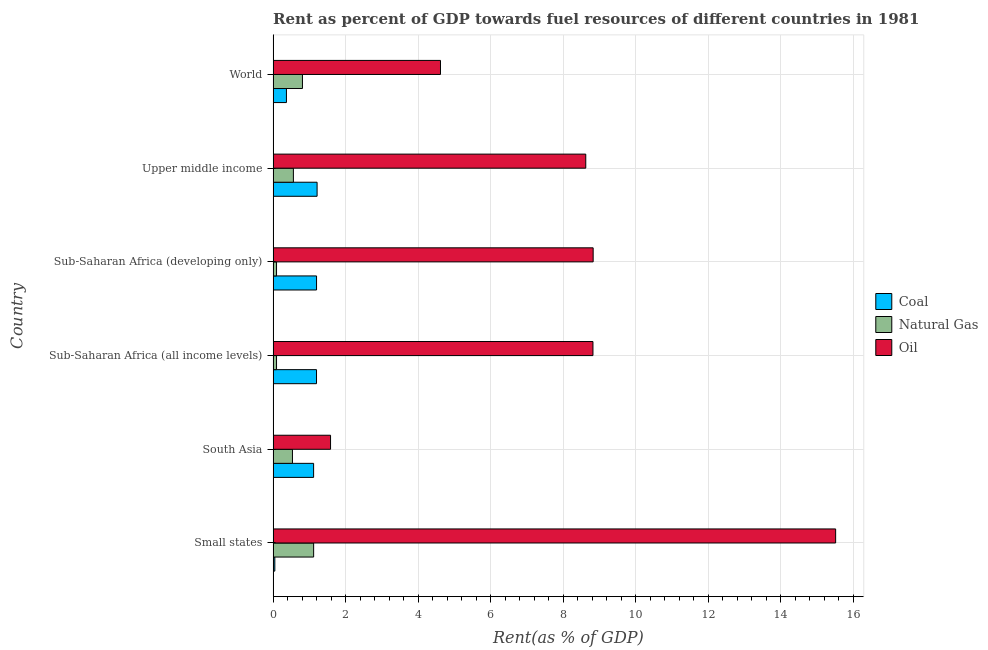How many different coloured bars are there?
Your response must be concise. 3. Are the number of bars per tick equal to the number of legend labels?
Your response must be concise. Yes. Are the number of bars on each tick of the Y-axis equal?
Your response must be concise. Yes. What is the label of the 5th group of bars from the top?
Ensure brevity in your answer.  South Asia. What is the rent towards oil in South Asia?
Your response must be concise. 1.58. Across all countries, what is the maximum rent towards coal?
Offer a very short reply. 1.21. Across all countries, what is the minimum rent towards coal?
Provide a short and direct response. 0.05. In which country was the rent towards oil maximum?
Provide a short and direct response. Small states. In which country was the rent towards natural gas minimum?
Provide a succinct answer. Sub-Saharan Africa (all income levels). What is the total rent towards coal in the graph?
Offer a terse response. 5.14. What is the difference between the rent towards natural gas in Sub-Saharan Africa (developing only) and that in Upper middle income?
Offer a very short reply. -0.47. What is the difference between the rent towards coal in World and the rent towards natural gas in Upper middle income?
Give a very brief answer. -0.19. What is the average rent towards oil per country?
Your answer should be very brief. 8. What is the difference between the rent towards coal and rent towards oil in Small states?
Offer a terse response. -15.46. In how many countries, is the rent towards oil greater than 4 %?
Your answer should be compact. 5. What is the ratio of the rent towards oil in Small states to that in Sub-Saharan Africa (all income levels)?
Provide a succinct answer. 1.76. Is the rent towards oil in South Asia less than that in Sub-Saharan Africa (all income levels)?
Provide a succinct answer. Yes. What is the difference between the highest and the second highest rent towards natural gas?
Ensure brevity in your answer.  0.31. What is the difference between the highest and the lowest rent towards coal?
Make the answer very short. 1.17. In how many countries, is the rent towards oil greater than the average rent towards oil taken over all countries?
Your answer should be very brief. 4. What does the 2nd bar from the top in Sub-Saharan Africa (developing only) represents?
Make the answer very short. Natural Gas. What does the 2nd bar from the bottom in Sub-Saharan Africa (all income levels) represents?
Offer a terse response. Natural Gas. How many bars are there?
Ensure brevity in your answer.  18. How many countries are there in the graph?
Ensure brevity in your answer.  6. Does the graph contain grids?
Offer a very short reply. Yes. Where does the legend appear in the graph?
Your answer should be very brief. Center right. How many legend labels are there?
Offer a terse response. 3. How are the legend labels stacked?
Provide a succinct answer. Vertical. What is the title of the graph?
Give a very brief answer. Rent as percent of GDP towards fuel resources of different countries in 1981. Does "Spain" appear as one of the legend labels in the graph?
Ensure brevity in your answer.  No. What is the label or title of the X-axis?
Keep it short and to the point. Rent(as % of GDP). What is the Rent(as % of GDP) in Coal in Small states?
Your response must be concise. 0.05. What is the Rent(as % of GDP) in Natural Gas in Small states?
Provide a succinct answer. 1.12. What is the Rent(as % of GDP) in Oil in Small states?
Your response must be concise. 15.51. What is the Rent(as % of GDP) of Coal in South Asia?
Give a very brief answer. 1.12. What is the Rent(as % of GDP) of Natural Gas in South Asia?
Ensure brevity in your answer.  0.53. What is the Rent(as % of GDP) of Oil in South Asia?
Offer a terse response. 1.58. What is the Rent(as % of GDP) of Coal in Sub-Saharan Africa (all income levels)?
Your answer should be very brief. 1.2. What is the Rent(as % of GDP) in Natural Gas in Sub-Saharan Africa (all income levels)?
Provide a short and direct response. 0.09. What is the Rent(as % of GDP) in Oil in Sub-Saharan Africa (all income levels)?
Provide a short and direct response. 8.82. What is the Rent(as % of GDP) of Coal in Sub-Saharan Africa (developing only)?
Keep it short and to the point. 1.2. What is the Rent(as % of GDP) in Natural Gas in Sub-Saharan Africa (developing only)?
Offer a very short reply. 0.09. What is the Rent(as % of GDP) of Oil in Sub-Saharan Africa (developing only)?
Give a very brief answer. 8.82. What is the Rent(as % of GDP) of Coal in Upper middle income?
Ensure brevity in your answer.  1.21. What is the Rent(as % of GDP) of Natural Gas in Upper middle income?
Ensure brevity in your answer.  0.56. What is the Rent(as % of GDP) of Oil in Upper middle income?
Provide a succinct answer. 8.62. What is the Rent(as % of GDP) of Coal in World?
Keep it short and to the point. 0.37. What is the Rent(as % of GDP) in Natural Gas in World?
Provide a succinct answer. 0.81. What is the Rent(as % of GDP) of Oil in World?
Your answer should be compact. 4.61. Across all countries, what is the maximum Rent(as % of GDP) in Coal?
Your answer should be compact. 1.21. Across all countries, what is the maximum Rent(as % of GDP) of Natural Gas?
Your response must be concise. 1.12. Across all countries, what is the maximum Rent(as % of GDP) in Oil?
Your answer should be compact. 15.51. Across all countries, what is the minimum Rent(as % of GDP) of Coal?
Offer a terse response. 0.05. Across all countries, what is the minimum Rent(as % of GDP) of Natural Gas?
Provide a succinct answer. 0.09. Across all countries, what is the minimum Rent(as % of GDP) in Oil?
Make the answer very short. 1.58. What is the total Rent(as % of GDP) of Coal in the graph?
Your answer should be very brief. 5.14. What is the total Rent(as % of GDP) of Natural Gas in the graph?
Keep it short and to the point. 3.21. What is the total Rent(as % of GDP) in Oil in the graph?
Keep it short and to the point. 47.97. What is the difference between the Rent(as % of GDP) in Coal in Small states and that in South Asia?
Your answer should be very brief. -1.07. What is the difference between the Rent(as % of GDP) in Natural Gas in Small states and that in South Asia?
Ensure brevity in your answer.  0.58. What is the difference between the Rent(as % of GDP) of Oil in Small states and that in South Asia?
Ensure brevity in your answer.  13.93. What is the difference between the Rent(as % of GDP) in Coal in Small states and that in Sub-Saharan Africa (all income levels)?
Your response must be concise. -1.15. What is the difference between the Rent(as % of GDP) of Natural Gas in Small states and that in Sub-Saharan Africa (all income levels)?
Provide a succinct answer. 1.02. What is the difference between the Rent(as % of GDP) of Oil in Small states and that in Sub-Saharan Africa (all income levels)?
Your response must be concise. 6.69. What is the difference between the Rent(as % of GDP) of Coal in Small states and that in Sub-Saharan Africa (developing only)?
Keep it short and to the point. -1.15. What is the difference between the Rent(as % of GDP) in Natural Gas in Small states and that in Sub-Saharan Africa (developing only)?
Your answer should be compact. 1.02. What is the difference between the Rent(as % of GDP) in Oil in Small states and that in Sub-Saharan Africa (developing only)?
Provide a short and direct response. 6.69. What is the difference between the Rent(as % of GDP) of Coal in Small states and that in Upper middle income?
Provide a short and direct response. -1.17. What is the difference between the Rent(as % of GDP) in Natural Gas in Small states and that in Upper middle income?
Your answer should be very brief. 0.56. What is the difference between the Rent(as % of GDP) in Oil in Small states and that in Upper middle income?
Offer a very short reply. 6.89. What is the difference between the Rent(as % of GDP) of Coal in Small states and that in World?
Your response must be concise. -0.32. What is the difference between the Rent(as % of GDP) of Natural Gas in Small states and that in World?
Your answer should be compact. 0.31. What is the difference between the Rent(as % of GDP) in Oil in Small states and that in World?
Offer a terse response. 10.9. What is the difference between the Rent(as % of GDP) of Coal in South Asia and that in Sub-Saharan Africa (all income levels)?
Your answer should be very brief. -0.08. What is the difference between the Rent(as % of GDP) in Natural Gas in South Asia and that in Sub-Saharan Africa (all income levels)?
Make the answer very short. 0.44. What is the difference between the Rent(as % of GDP) of Oil in South Asia and that in Sub-Saharan Africa (all income levels)?
Ensure brevity in your answer.  -7.23. What is the difference between the Rent(as % of GDP) in Coal in South Asia and that in Sub-Saharan Africa (developing only)?
Make the answer very short. -0.08. What is the difference between the Rent(as % of GDP) of Natural Gas in South Asia and that in Sub-Saharan Africa (developing only)?
Your response must be concise. 0.44. What is the difference between the Rent(as % of GDP) of Oil in South Asia and that in Sub-Saharan Africa (developing only)?
Your answer should be compact. -7.24. What is the difference between the Rent(as % of GDP) in Coal in South Asia and that in Upper middle income?
Your answer should be very brief. -0.1. What is the difference between the Rent(as % of GDP) in Natural Gas in South Asia and that in Upper middle income?
Make the answer very short. -0.03. What is the difference between the Rent(as % of GDP) in Oil in South Asia and that in Upper middle income?
Your answer should be compact. -7.04. What is the difference between the Rent(as % of GDP) of Coal in South Asia and that in World?
Your response must be concise. 0.75. What is the difference between the Rent(as % of GDP) in Natural Gas in South Asia and that in World?
Your answer should be very brief. -0.28. What is the difference between the Rent(as % of GDP) of Oil in South Asia and that in World?
Ensure brevity in your answer.  -3.03. What is the difference between the Rent(as % of GDP) of Coal in Sub-Saharan Africa (all income levels) and that in Sub-Saharan Africa (developing only)?
Your response must be concise. -0. What is the difference between the Rent(as % of GDP) of Natural Gas in Sub-Saharan Africa (all income levels) and that in Sub-Saharan Africa (developing only)?
Your answer should be very brief. -0. What is the difference between the Rent(as % of GDP) of Oil in Sub-Saharan Africa (all income levels) and that in Sub-Saharan Africa (developing only)?
Give a very brief answer. -0.01. What is the difference between the Rent(as % of GDP) in Coal in Sub-Saharan Africa (all income levels) and that in Upper middle income?
Your answer should be compact. -0.02. What is the difference between the Rent(as % of GDP) in Natural Gas in Sub-Saharan Africa (all income levels) and that in Upper middle income?
Provide a short and direct response. -0.46. What is the difference between the Rent(as % of GDP) in Oil in Sub-Saharan Africa (all income levels) and that in Upper middle income?
Provide a succinct answer. 0.2. What is the difference between the Rent(as % of GDP) in Coal in Sub-Saharan Africa (all income levels) and that in World?
Give a very brief answer. 0.83. What is the difference between the Rent(as % of GDP) in Natural Gas in Sub-Saharan Africa (all income levels) and that in World?
Keep it short and to the point. -0.71. What is the difference between the Rent(as % of GDP) in Oil in Sub-Saharan Africa (all income levels) and that in World?
Your response must be concise. 4.2. What is the difference between the Rent(as % of GDP) of Coal in Sub-Saharan Africa (developing only) and that in Upper middle income?
Your response must be concise. -0.01. What is the difference between the Rent(as % of GDP) in Natural Gas in Sub-Saharan Africa (developing only) and that in Upper middle income?
Provide a succinct answer. -0.46. What is the difference between the Rent(as % of GDP) of Oil in Sub-Saharan Africa (developing only) and that in Upper middle income?
Your response must be concise. 0.2. What is the difference between the Rent(as % of GDP) in Coal in Sub-Saharan Africa (developing only) and that in World?
Offer a terse response. 0.83. What is the difference between the Rent(as % of GDP) of Natural Gas in Sub-Saharan Africa (developing only) and that in World?
Keep it short and to the point. -0.71. What is the difference between the Rent(as % of GDP) of Oil in Sub-Saharan Africa (developing only) and that in World?
Offer a terse response. 4.21. What is the difference between the Rent(as % of GDP) of Coal in Upper middle income and that in World?
Your answer should be compact. 0.85. What is the difference between the Rent(as % of GDP) of Natural Gas in Upper middle income and that in World?
Provide a short and direct response. -0.25. What is the difference between the Rent(as % of GDP) in Oil in Upper middle income and that in World?
Ensure brevity in your answer.  4.01. What is the difference between the Rent(as % of GDP) of Coal in Small states and the Rent(as % of GDP) of Natural Gas in South Asia?
Your answer should be compact. -0.49. What is the difference between the Rent(as % of GDP) in Coal in Small states and the Rent(as % of GDP) in Oil in South Asia?
Keep it short and to the point. -1.54. What is the difference between the Rent(as % of GDP) of Natural Gas in Small states and the Rent(as % of GDP) of Oil in South Asia?
Your response must be concise. -0.47. What is the difference between the Rent(as % of GDP) of Coal in Small states and the Rent(as % of GDP) of Natural Gas in Sub-Saharan Africa (all income levels)?
Your answer should be compact. -0.05. What is the difference between the Rent(as % of GDP) of Coal in Small states and the Rent(as % of GDP) of Oil in Sub-Saharan Africa (all income levels)?
Offer a terse response. -8.77. What is the difference between the Rent(as % of GDP) in Natural Gas in Small states and the Rent(as % of GDP) in Oil in Sub-Saharan Africa (all income levels)?
Offer a terse response. -7.7. What is the difference between the Rent(as % of GDP) of Coal in Small states and the Rent(as % of GDP) of Natural Gas in Sub-Saharan Africa (developing only)?
Offer a very short reply. -0.05. What is the difference between the Rent(as % of GDP) in Coal in Small states and the Rent(as % of GDP) in Oil in Sub-Saharan Africa (developing only)?
Offer a terse response. -8.78. What is the difference between the Rent(as % of GDP) of Natural Gas in Small states and the Rent(as % of GDP) of Oil in Sub-Saharan Africa (developing only)?
Keep it short and to the point. -7.71. What is the difference between the Rent(as % of GDP) of Coal in Small states and the Rent(as % of GDP) of Natural Gas in Upper middle income?
Your answer should be very brief. -0.51. What is the difference between the Rent(as % of GDP) in Coal in Small states and the Rent(as % of GDP) in Oil in Upper middle income?
Provide a short and direct response. -8.57. What is the difference between the Rent(as % of GDP) in Natural Gas in Small states and the Rent(as % of GDP) in Oil in Upper middle income?
Make the answer very short. -7.5. What is the difference between the Rent(as % of GDP) of Coal in Small states and the Rent(as % of GDP) of Natural Gas in World?
Ensure brevity in your answer.  -0.76. What is the difference between the Rent(as % of GDP) of Coal in Small states and the Rent(as % of GDP) of Oil in World?
Make the answer very short. -4.57. What is the difference between the Rent(as % of GDP) of Natural Gas in Small states and the Rent(as % of GDP) of Oil in World?
Provide a short and direct response. -3.5. What is the difference between the Rent(as % of GDP) in Coal in South Asia and the Rent(as % of GDP) in Natural Gas in Sub-Saharan Africa (all income levels)?
Provide a short and direct response. 1.02. What is the difference between the Rent(as % of GDP) of Coal in South Asia and the Rent(as % of GDP) of Oil in Sub-Saharan Africa (all income levels)?
Provide a succinct answer. -7.7. What is the difference between the Rent(as % of GDP) of Natural Gas in South Asia and the Rent(as % of GDP) of Oil in Sub-Saharan Africa (all income levels)?
Ensure brevity in your answer.  -8.29. What is the difference between the Rent(as % of GDP) of Coal in South Asia and the Rent(as % of GDP) of Natural Gas in Sub-Saharan Africa (developing only)?
Your response must be concise. 1.02. What is the difference between the Rent(as % of GDP) in Coal in South Asia and the Rent(as % of GDP) in Oil in Sub-Saharan Africa (developing only)?
Make the answer very short. -7.71. What is the difference between the Rent(as % of GDP) of Natural Gas in South Asia and the Rent(as % of GDP) of Oil in Sub-Saharan Africa (developing only)?
Offer a very short reply. -8.29. What is the difference between the Rent(as % of GDP) in Coal in South Asia and the Rent(as % of GDP) in Natural Gas in Upper middle income?
Make the answer very short. 0.56. What is the difference between the Rent(as % of GDP) in Coal in South Asia and the Rent(as % of GDP) in Oil in Upper middle income?
Provide a short and direct response. -7.5. What is the difference between the Rent(as % of GDP) of Natural Gas in South Asia and the Rent(as % of GDP) of Oil in Upper middle income?
Provide a short and direct response. -8.09. What is the difference between the Rent(as % of GDP) in Coal in South Asia and the Rent(as % of GDP) in Natural Gas in World?
Keep it short and to the point. 0.31. What is the difference between the Rent(as % of GDP) in Coal in South Asia and the Rent(as % of GDP) in Oil in World?
Offer a terse response. -3.5. What is the difference between the Rent(as % of GDP) in Natural Gas in South Asia and the Rent(as % of GDP) in Oil in World?
Provide a succinct answer. -4.08. What is the difference between the Rent(as % of GDP) in Coal in Sub-Saharan Africa (all income levels) and the Rent(as % of GDP) in Natural Gas in Sub-Saharan Africa (developing only)?
Keep it short and to the point. 1.1. What is the difference between the Rent(as % of GDP) of Coal in Sub-Saharan Africa (all income levels) and the Rent(as % of GDP) of Oil in Sub-Saharan Africa (developing only)?
Your response must be concise. -7.63. What is the difference between the Rent(as % of GDP) of Natural Gas in Sub-Saharan Africa (all income levels) and the Rent(as % of GDP) of Oil in Sub-Saharan Africa (developing only)?
Make the answer very short. -8.73. What is the difference between the Rent(as % of GDP) of Coal in Sub-Saharan Africa (all income levels) and the Rent(as % of GDP) of Natural Gas in Upper middle income?
Offer a terse response. 0.64. What is the difference between the Rent(as % of GDP) in Coal in Sub-Saharan Africa (all income levels) and the Rent(as % of GDP) in Oil in Upper middle income?
Give a very brief answer. -7.42. What is the difference between the Rent(as % of GDP) in Natural Gas in Sub-Saharan Africa (all income levels) and the Rent(as % of GDP) in Oil in Upper middle income?
Offer a very short reply. -8.53. What is the difference between the Rent(as % of GDP) in Coal in Sub-Saharan Africa (all income levels) and the Rent(as % of GDP) in Natural Gas in World?
Your answer should be compact. 0.39. What is the difference between the Rent(as % of GDP) of Coal in Sub-Saharan Africa (all income levels) and the Rent(as % of GDP) of Oil in World?
Make the answer very short. -3.42. What is the difference between the Rent(as % of GDP) of Natural Gas in Sub-Saharan Africa (all income levels) and the Rent(as % of GDP) of Oil in World?
Provide a short and direct response. -4.52. What is the difference between the Rent(as % of GDP) in Coal in Sub-Saharan Africa (developing only) and the Rent(as % of GDP) in Natural Gas in Upper middle income?
Your answer should be compact. 0.64. What is the difference between the Rent(as % of GDP) of Coal in Sub-Saharan Africa (developing only) and the Rent(as % of GDP) of Oil in Upper middle income?
Offer a very short reply. -7.42. What is the difference between the Rent(as % of GDP) in Natural Gas in Sub-Saharan Africa (developing only) and the Rent(as % of GDP) in Oil in Upper middle income?
Offer a very short reply. -8.53. What is the difference between the Rent(as % of GDP) in Coal in Sub-Saharan Africa (developing only) and the Rent(as % of GDP) in Natural Gas in World?
Give a very brief answer. 0.39. What is the difference between the Rent(as % of GDP) in Coal in Sub-Saharan Africa (developing only) and the Rent(as % of GDP) in Oil in World?
Offer a terse response. -3.42. What is the difference between the Rent(as % of GDP) in Natural Gas in Sub-Saharan Africa (developing only) and the Rent(as % of GDP) in Oil in World?
Provide a succinct answer. -4.52. What is the difference between the Rent(as % of GDP) of Coal in Upper middle income and the Rent(as % of GDP) of Natural Gas in World?
Give a very brief answer. 0.4. What is the difference between the Rent(as % of GDP) in Coal in Upper middle income and the Rent(as % of GDP) in Oil in World?
Make the answer very short. -3.4. What is the difference between the Rent(as % of GDP) of Natural Gas in Upper middle income and the Rent(as % of GDP) of Oil in World?
Give a very brief answer. -4.06. What is the average Rent(as % of GDP) in Coal per country?
Offer a terse response. 0.86. What is the average Rent(as % of GDP) of Natural Gas per country?
Your answer should be very brief. 0.53. What is the average Rent(as % of GDP) in Oil per country?
Provide a succinct answer. 8. What is the difference between the Rent(as % of GDP) of Coal and Rent(as % of GDP) of Natural Gas in Small states?
Your answer should be very brief. -1.07. What is the difference between the Rent(as % of GDP) of Coal and Rent(as % of GDP) of Oil in Small states?
Offer a very short reply. -15.46. What is the difference between the Rent(as % of GDP) of Natural Gas and Rent(as % of GDP) of Oil in Small states?
Provide a succinct answer. -14.39. What is the difference between the Rent(as % of GDP) of Coal and Rent(as % of GDP) of Natural Gas in South Asia?
Ensure brevity in your answer.  0.58. What is the difference between the Rent(as % of GDP) of Coal and Rent(as % of GDP) of Oil in South Asia?
Ensure brevity in your answer.  -0.47. What is the difference between the Rent(as % of GDP) of Natural Gas and Rent(as % of GDP) of Oil in South Asia?
Provide a succinct answer. -1.05. What is the difference between the Rent(as % of GDP) in Coal and Rent(as % of GDP) in Natural Gas in Sub-Saharan Africa (all income levels)?
Provide a succinct answer. 1.1. What is the difference between the Rent(as % of GDP) of Coal and Rent(as % of GDP) of Oil in Sub-Saharan Africa (all income levels)?
Your answer should be compact. -7.62. What is the difference between the Rent(as % of GDP) in Natural Gas and Rent(as % of GDP) in Oil in Sub-Saharan Africa (all income levels)?
Your answer should be very brief. -8.72. What is the difference between the Rent(as % of GDP) of Coal and Rent(as % of GDP) of Natural Gas in Sub-Saharan Africa (developing only)?
Your response must be concise. 1.1. What is the difference between the Rent(as % of GDP) in Coal and Rent(as % of GDP) in Oil in Sub-Saharan Africa (developing only)?
Your answer should be compact. -7.63. What is the difference between the Rent(as % of GDP) of Natural Gas and Rent(as % of GDP) of Oil in Sub-Saharan Africa (developing only)?
Your answer should be compact. -8.73. What is the difference between the Rent(as % of GDP) of Coal and Rent(as % of GDP) of Natural Gas in Upper middle income?
Offer a terse response. 0.65. What is the difference between the Rent(as % of GDP) of Coal and Rent(as % of GDP) of Oil in Upper middle income?
Ensure brevity in your answer.  -7.41. What is the difference between the Rent(as % of GDP) in Natural Gas and Rent(as % of GDP) in Oil in Upper middle income?
Give a very brief answer. -8.06. What is the difference between the Rent(as % of GDP) in Coal and Rent(as % of GDP) in Natural Gas in World?
Your answer should be compact. -0.44. What is the difference between the Rent(as % of GDP) in Coal and Rent(as % of GDP) in Oil in World?
Make the answer very short. -4.25. What is the difference between the Rent(as % of GDP) of Natural Gas and Rent(as % of GDP) of Oil in World?
Keep it short and to the point. -3.81. What is the ratio of the Rent(as % of GDP) in Coal in Small states to that in South Asia?
Your response must be concise. 0.04. What is the ratio of the Rent(as % of GDP) in Natural Gas in Small states to that in South Asia?
Offer a terse response. 2.1. What is the ratio of the Rent(as % of GDP) in Oil in Small states to that in South Asia?
Give a very brief answer. 9.79. What is the ratio of the Rent(as % of GDP) in Coal in Small states to that in Sub-Saharan Africa (all income levels)?
Provide a succinct answer. 0.04. What is the ratio of the Rent(as % of GDP) in Natural Gas in Small states to that in Sub-Saharan Africa (all income levels)?
Keep it short and to the point. 11.89. What is the ratio of the Rent(as % of GDP) of Oil in Small states to that in Sub-Saharan Africa (all income levels)?
Provide a short and direct response. 1.76. What is the ratio of the Rent(as % of GDP) of Coal in Small states to that in Sub-Saharan Africa (developing only)?
Provide a short and direct response. 0.04. What is the ratio of the Rent(as % of GDP) in Natural Gas in Small states to that in Sub-Saharan Africa (developing only)?
Provide a succinct answer. 11.89. What is the ratio of the Rent(as % of GDP) in Oil in Small states to that in Sub-Saharan Africa (developing only)?
Keep it short and to the point. 1.76. What is the ratio of the Rent(as % of GDP) in Coal in Small states to that in Upper middle income?
Make the answer very short. 0.04. What is the ratio of the Rent(as % of GDP) in Natural Gas in Small states to that in Upper middle income?
Your response must be concise. 2. What is the ratio of the Rent(as % of GDP) of Oil in Small states to that in Upper middle income?
Your answer should be compact. 1.8. What is the ratio of the Rent(as % of GDP) in Coal in Small states to that in World?
Offer a terse response. 0.13. What is the ratio of the Rent(as % of GDP) of Natural Gas in Small states to that in World?
Provide a succinct answer. 1.38. What is the ratio of the Rent(as % of GDP) in Oil in Small states to that in World?
Offer a very short reply. 3.36. What is the ratio of the Rent(as % of GDP) of Coal in South Asia to that in Sub-Saharan Africa (all income levels)?
Provide a short and direct response. 0.93. What is the ratio of the Rent(as % of GDP) of Natural Gas in South Asia to that in Sub-Saharan Africa (all income levels)?
Your answer should be very brief. 5.68. What is the ratio of the Rent(as % of GDP) of Oil in South Asia to that in Sub-Saharan Africa (all income levels)?
Provide a succinct answer. 0.18. What is the ratio of the Rent(as % of GDP) in Coal in South Asia to that in Sub-Saharan Africa (developing only)?
Keep it short and to the point. 0.93. What is the ratio of the Rent(as % of GDP) in Natural Gas in South Asia to that in Sub-Saharan Africa (developing only)?
Your answer should be very brief. 5.67. What is the ratio of the Rent(as % of GDP) of Oil in South Asia to that in Sub-Saharan Africa (developing only)?
Provide a short and direct response. 0.18. What is the ratio of the Rent(as % of GDP) of Coal in South Asia to that in Upper middle income?
Your answer should be compact. 0.92. What is the ratio of the Rent(as % of GDP) in Natural Gas in South Asia to that in Upper middle income?
Provide a succinct answer. 0.95. What is the ratio of the Rent(as % of GDP) in Oil in South Asia to that in Upper middle income?
Offer a very short reply. 0.18. What is the ratio of the Rent(as % of GDP) of Coal in South Asia to that in World?
Your response must be concise. 3.04. What is the ratio of the Rent(as % of GDP) of Natural Gas in South Asia to that in World?
Offer a very short reply. 0.66. What is the ratio of the Rent(as % of GDP) of Oil in South Asia to that in World?
Provide a short and direct response. 0.34. What is the ratio of the Rent(as % of GDP) in Natural Gas in Sub-Saharan Africa (all income levels) to that in Sub-Saharan Africa (developing only)?
Offer a very short reply. 1. What is the ratio of the Rent(as % of GDP) in Oil in Sub-Saharan Africa (all income levels) to that in Sub-Saharan Africa (developing only)?
Make the answer very short. 1. What is the ratio of the Rent(as % of GDP) of Coal in Sub-Saharan Africa (all income levels) to that in Upper middle income?
Give a very brief answer. 0.99. What is the ratio of the Rent(as % of GDP) in Natural Gas in Sub-Saharan Africa (all income levels) to that in Upper middle income?
Your response must be concise. 0.17. What is the ratio of the Rent(as % of GDP) of Coal in Sub-Saharan Africa (all income levels) to that in World?
Offer a terse response. 3.26. What is the ratio of the Rent(as % of GDP) of Natural Gas in Sub-Saharan Africa (all income levels) to that in World?
Provide a short and direct response. 0.12. What is the ratio of the Rent(as % of GDP) of Oil in Sub-Saharan Africa (all income levels) to that in World?
Provide a succinct answer. 1.91. What is the ratio of the Rent(as % of GDP) of Coal in Sub-Saharan Africa (developing only) to that in Upper middle income?
Offer a very short reply. 0.99. What is the ratio of the Rent(as % of GDP) in Natural Gas in Sub-Saharan Africa (developing only) to that in Upper middle income?
Your response must be concise. 0.17. What is the ratio of the Rent(as % of GDP) of Oil in Sub-Saharan Africa (developing only) to that in Upper middle income?
Provide a short and direct response. 1.02. What is the ratio of the Rent(as % of GDP) of Coal in Sub-Saharan Africa (developing only) to that in World?
Provide a short and direct response. 3.26. What is the ratio of the Rent(as % of GDP) in Natural Gas in Sub-Saharan Africa (developing only) to that in World?
Your answer should be very brief. 0.12. What is the ratio of the Rent(as % of GDP) of Oil in Sub-Saharan Africa (developing only) to that in World?
Your response must be concise. 1.91. What is the ratio of the Rent(as % of GDP) in Coal in Upper middle income to that in World?
Your response must be concise. 3.3. What is the ratio of the Rent(as % of GDP) of Natural Gas in Upper middle income to that in World?
Your answer should be very brief. 0.69. What is the ratio of the Rent(as % of GDP) of Oil in Upper middle income to that in World?
Give a very brief answer. 1.87. What is the difference between the highest and the second highest Rent(as % of GDP) in Coal?
Give a very brief answer. 0.01. What is the difference between the highest and the second highest Rent(as % of GDP) in Natural Gas?
Offer a terse response. 0.31. What is the difference between the highest and the second highest Rent(as % of GDP) in Oil?
Offer a very short reply. 6.69. What is the difference between the highest and the lowest Rent(as % of GDP) in Coal?
Your answer should be compact. 1.17. What is the difference between the highest and the lowest Rent(as % of GDP) in Natural Gas?
Keep it short and to the point. 1.02. What is the difference between the highest and the lowest Rent(as % of GDP) in Oil?
Provide a succinct answer. 13.93. 